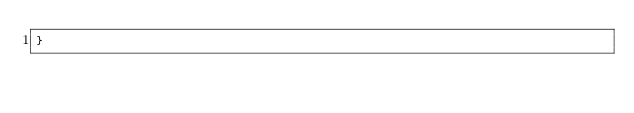<code> <loc_0><loc_0><loc_500><loc_500><_JavaScript_>}</code> 